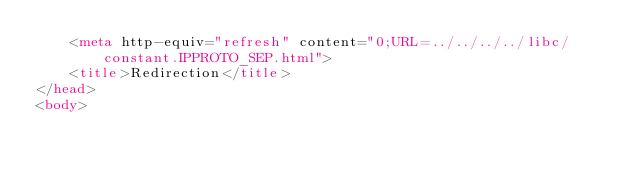<code> <loc_0><loc_0><loc_500><loc_500><_HTML_>    <meta http-equiv="refresh" content="0;URL=../../../../libc/constant.IPPROTO_SEP.html">
    <title>Redirection</title>
</head>
<body></code> 